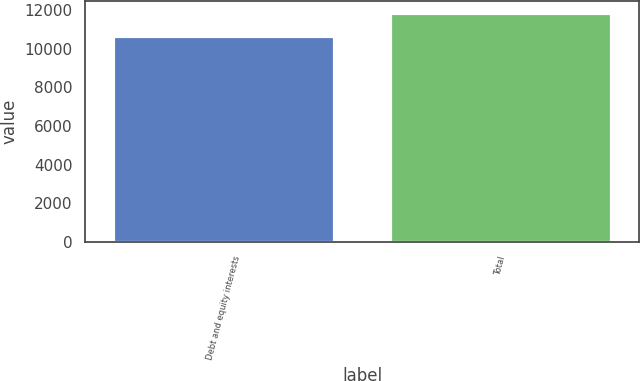Convert chart to OTSL. <chart><loc_0><loc_0><loc_500><loc_500><bar_chart><fcel>Debt and equity interests<fcel>Total<nl><fcel>10657<fcel>11871<nl></chart> 